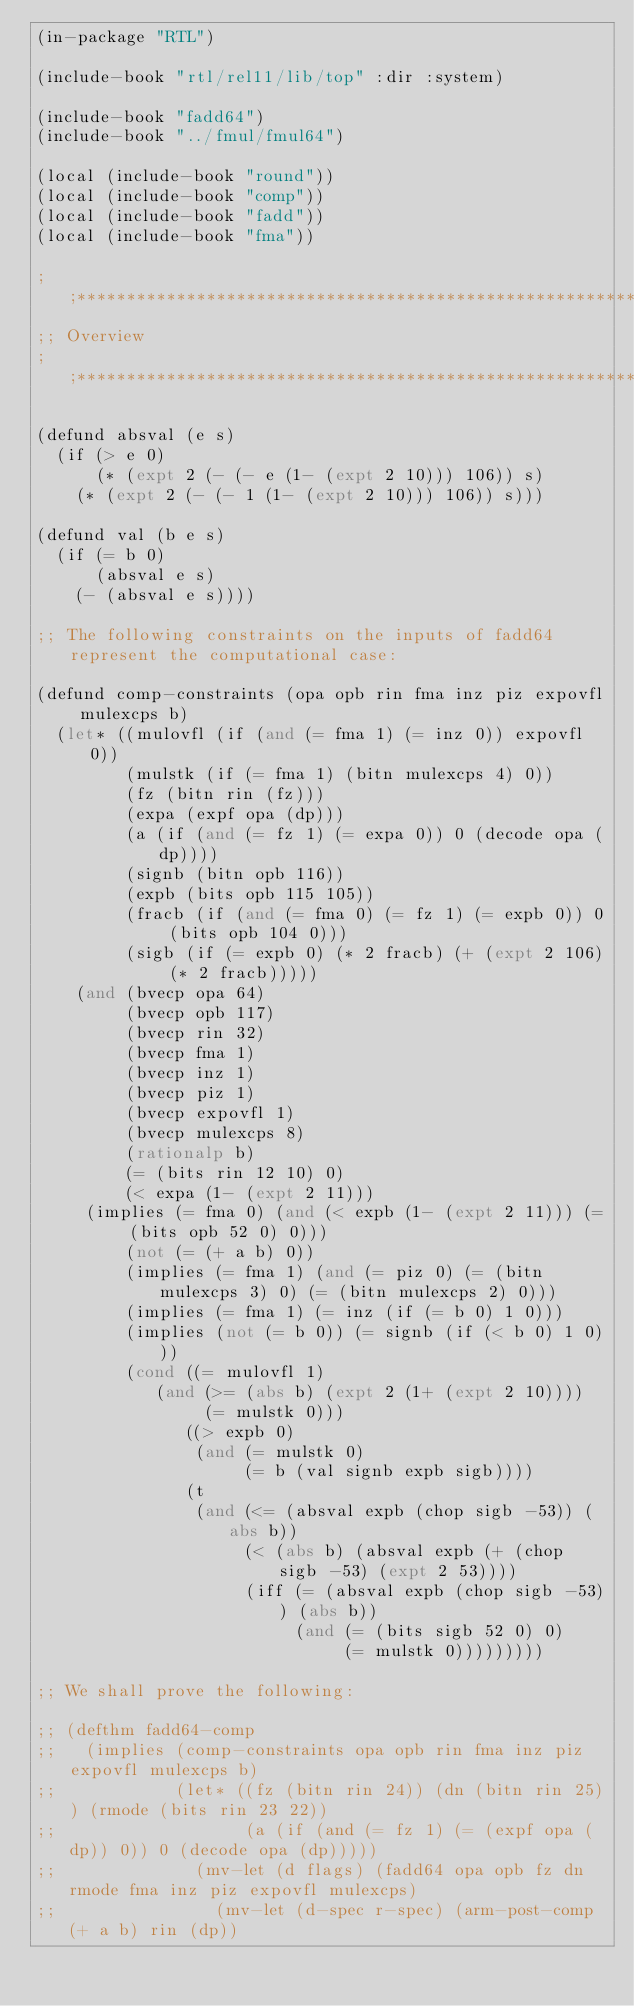<code> <loc_0><loc_0><loc_500><loc_500><_Lisp_>(in-package "RTL")

(include-book "rtl/rel11/lib/top" :dir :system)

(include-book "fadd64")
(include-book "../fmul/fmul64")

(local (include-book "round"))
(local (include-book "comp"))
(local (include-book "fadd"))
(local (include-book "fma"))

;;*******************************************************************************
;; Overview
;;*******************************************************************************

(defund absval (e s)
  (if (> e 0)
      (* (expt 2 (- (- e (1- (expt 2 10))) 106)) s)
    (* (expt 2 (- (- 1 (1- (expt 2 10))) 106)) s)))

(defund val (b e s)
  (if (= b 0)
      (absval e s)
    (- (absval e s))))

;; The following constraints on the inputs of fadd64 represent the computational case:

(defund comp-constraints (opa opb rin fma inz piz expovfl mulexcps b)
  (let* ((mulovfl (if (and (= fma 1) (= inz 0)) expovfl 0))
         (mulstk (if (= fma 1) (bitn mulexcps 4) 0))
         (fz (bitn rin (fz)))
         (expa (expf opa (dp)))
         (a (if (and (= fz 1) (= expa 0)) 0 (decode opa (dp))))
         (signb (bitn opb 116))
         (expb (bits opb 115 105))
         (fracb (if (and (= fma 0) (= fz 1) (= expb 0)) 0 (bits opb 104 0)))
         (sigb (if (= expb 0) (* 2 fracb) (+ (expt 2 106) (* 2 fracb)))))
    (and (bvecp opa 64)
         (bvecp opb 117)
         (bvecp rin 32)
         (bvecp fma 1)
         (bvecp inz 1)
         (bvecp piz 1)
         (bvecp expovfl 1)
         (bvecp mulexcps 8)
         (rationalp b)
         (= (bits rin 12 10) 0)
         (< expa (1- (expt 2 11)))
	 (implies (= fma 0) (and (< expb (1- (expt 2 11))) (= (bits opb 52 0) 0)))
         (not (= (+ a b) 0))
         (implies (= fma 1) (and (= piz 0) (= (bitn mulexcps 3) 0) (= (bitn mulexcps 2) 0)))
         (implies (= fma 1) (= inz (if (= b 0) 1 0)))
         (implies (not (= b 0)) (= signb (if (< b 0) 1 0)))
         (cond ((= mulovfl 1)
	        (and (>= (abs b) (expt 2 (1+ (expt 2 10))))
	             (= mulstk 0)))
               ((> expb 0)
                (and (= mulstk 0)
                     (= b (val signb expb sigb))))
               (t
                (and (<= (absval expb (chop sigb -53)) (abs b))
                     (< (abs b) (absval expb (+ (chop sigb -53) (expt 2 53))))
                     (iff (= (absval expb (chop sigb -53)) (abs b))
                          (and (= (bits sigb 52 0) 0)
                               (= mulstk 0)))))))))

;; We shall prove the following:

;; (defthm fadd64-comp
;;   (implies (comp-constraints opa opb rin fma inz piz expovfl mulexcps b)
;;            (let* ((fz (bitn rin 24)) (dn (bitn rin 25)) (rmode (bits rin 23 22))
;;                   (a (if (and (= fz 1) (= (expf opa (dp)) 0)) 0 (decode opa (dp)))))
;;              (mv-let (d flags) (fadd64 opa opb fz dn rmode fma inz piz expovfl mulexcps)
;;                (mv-let (d-spec r-spec) (arm-post-comp (+ a b) rin (dp))</code> 